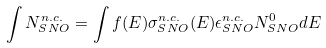<formula> <loc_0><loc_0><loc_500><loc_500>\int N _ { S N O } ^ { n . c . } = \int f ( E ) \sigma ^ { n . c . } _ { S N O } ( E ) \epsilon ^ { n . c . } _ { S N O } N ^ { 0 } _ { S N O } d E</formula> 